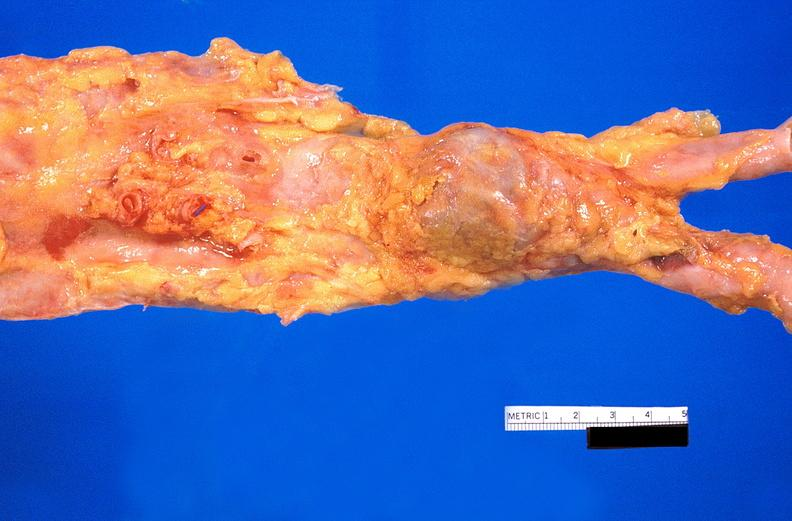where is this?
Answer the question using a single word or phrase. Aorta 